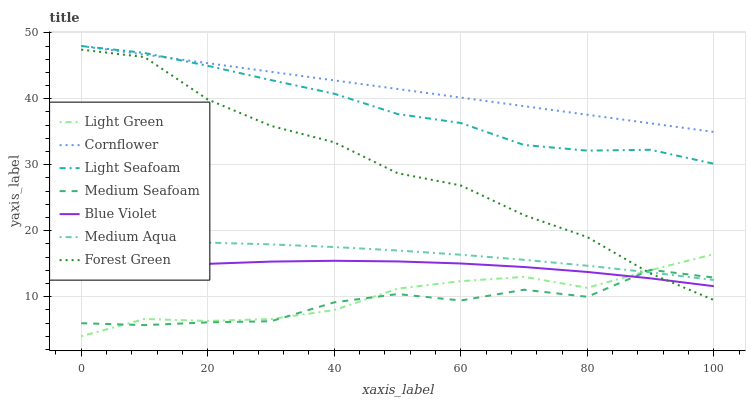Does Medium Seafoam have the minimum area under the curve?
Answer yes or no. Yes. Does Cornflower have the maximum area under the curve?
Answer yes or no. Yes. Does Forest Green have the minimum area under the curve?
Answer yes or no. No. Does Forest Green have the maximum area under the curve?
Answer yes or no. No. Is Cornflower the smoothest?
Answer yes or no. Yes. Is Medium Seafoam the roughest?
Answer yes or no. Yes. Is Forest Green the smoothest?
Answer yes or no. No. Is Forest Green the roughest?
Answer yes or no. No. Does Light Green have the lowest value?
Answer yes or no. Yes. Does Forest Green have the lowest value?
Answer yes or no. No. Does Light Seafoam have the highest value?
Answer yes or no. Yes. Does Forest Green have the highest value?
Answer yes or no. No. Is Blue Violet less than Light Seafoam?
Answer yes or no. Yes. Is Cornflower greater than Blue Violet?
Answer yes or no. Yes. Does Medium Seafoam intersect Light Green?
Answer yes or no. Yes. Is Medium Seafoam less than Light Green?
Answer yes or no. No. Is Medium Seafoam greater than Light Green?
Answer yes or no. No. Does Blue Violet intersect Light Seafoam?
Answer yes or no. No. 